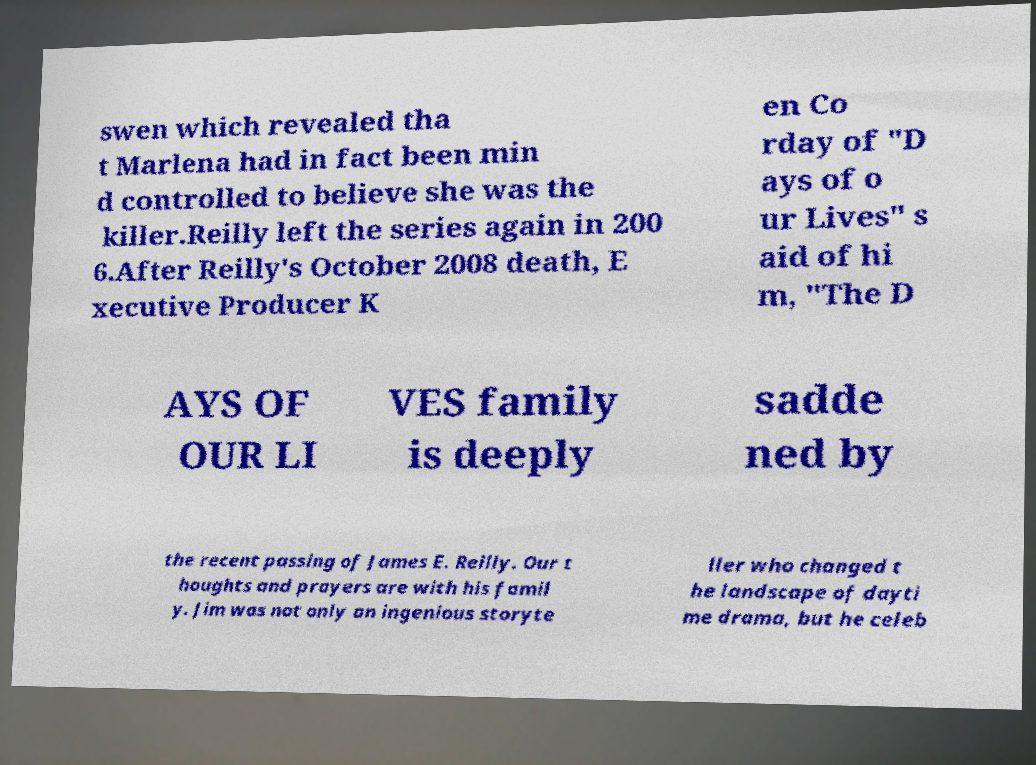Can you accurately transcribe the text from the provided image for me? swen which revealed tha t Marlena had in fact been min d controlled to believe she was the killer.Reilly left the series again in 200 6.After Reilly's October 2008 death, E xecutive Producer K en Co rday of "D ays of o ur Lives" s aid of hi m, "The D AYS OF OUR LI VES family is deeply sadde ned by the recent passing of James E. Reilly. Our t houghts and prayers are with his famil y. Jim was not only an ingenious storyte ller who changed t he landscape of dayti me drama, but he celeb 